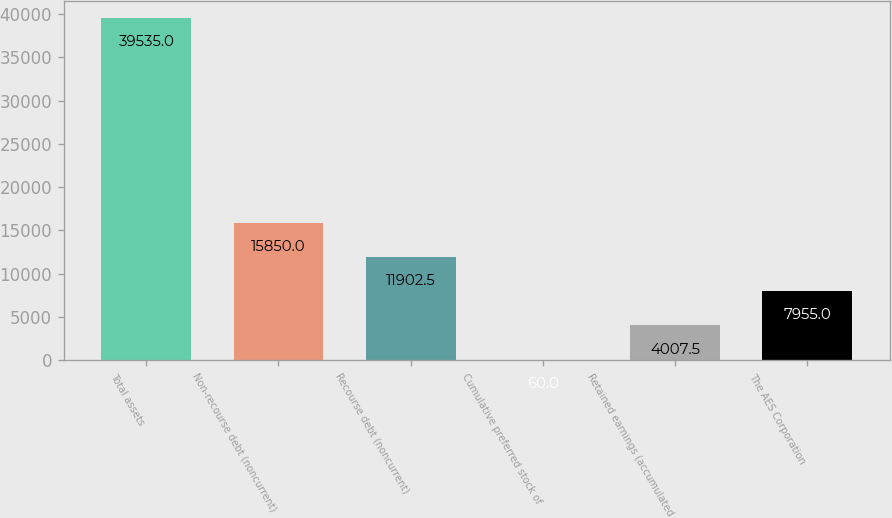Convert chart to OTSL. <chart><loc_0><loc_0><loc_500><loc_500><bar_chart><fcel>Total assets<fcel>Non-recourse debt (noncurrent)<fcel>Recourse debt (noncurrent)<fcel>Cumulative preferred stock of<fcel>Retained earnings (accumulated<fcel>The AES Corporation<nl><fcel>39535<fcel>15850<fcel>11902.5<fcel>60<fcel>4007.5<fcel>7955<nl></chart> 